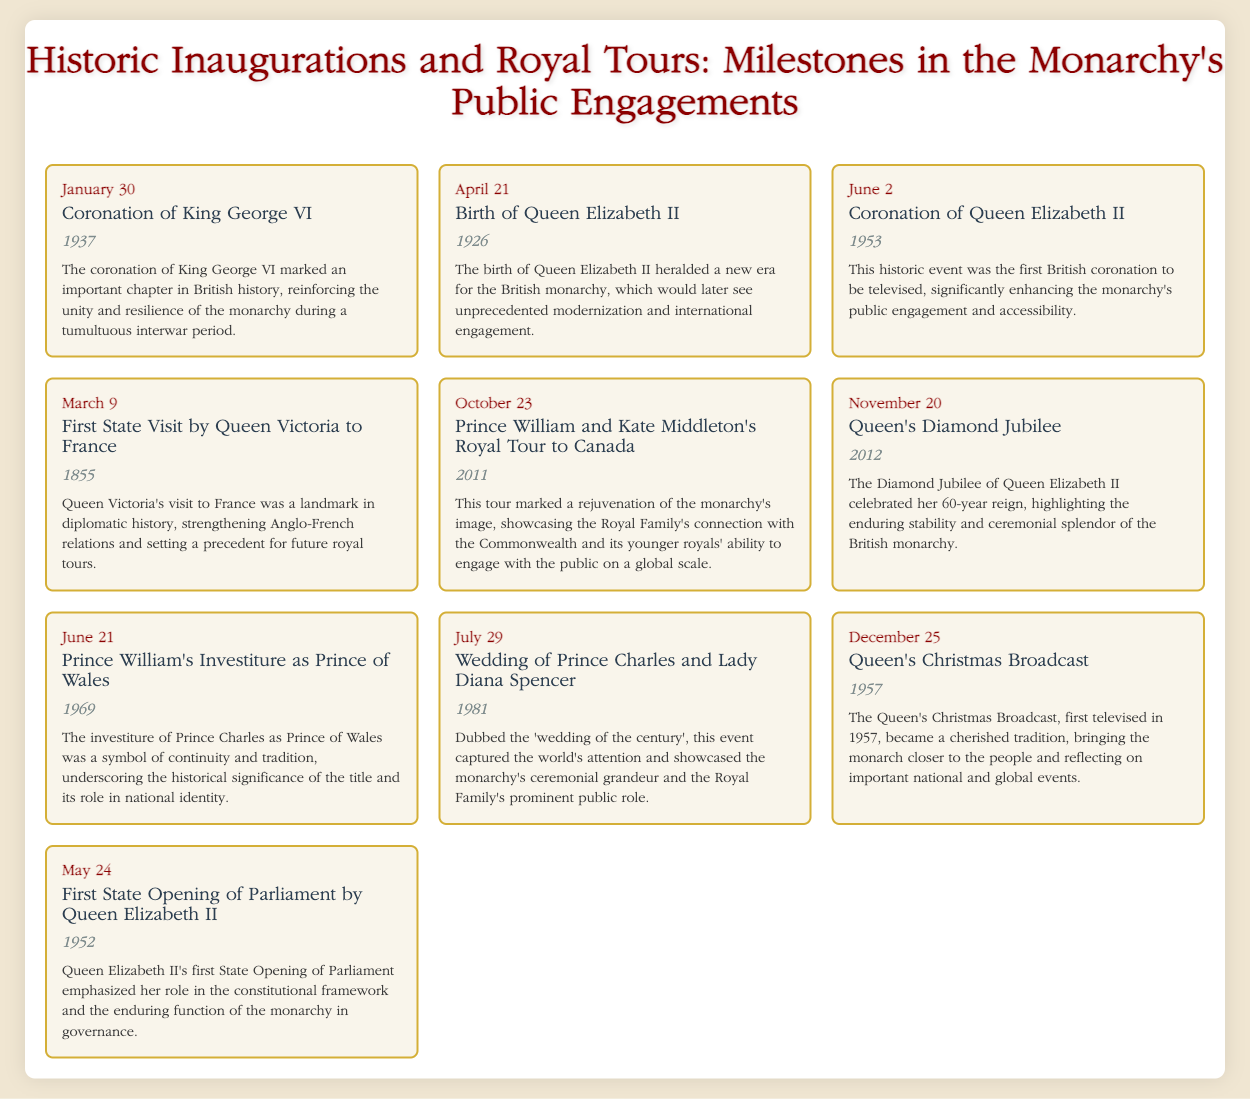what date is the coronation of King George VI? The document specifies that the coronation of King George VI took place on January 30.
Answer: January 30 what year was Queen Elizabeth II born? According to the document, Queen Elizabeth II was born in 1926.
Answer: 1926 what significant event took place on June 2, 1953? The document describes this date as the coronation of Queen Elizabeth II.
Answer: Coronation of Queen Elizabeth II how did Queen Victoria's first state visit impact Anglo-French relations? The document notes that this visit strengthened Anglo-French relations and set a precedent for future royal tours.
Answer: Strengthened Anglo-French relations what was the public response to the wedding of Prince Charles and Lady Diana Spencer? According to the document, this wedding was dubbed the "wedding of the century," capturing worldwide attention.
Answer: Wedding of the century how does the document describe the significance of the Diamond Jubilee of Queen Elizabeth II? The document highlights the Diamond Jubilee as a celebration of her 60-year reign, emphasizing stability and ceremonial splendor.
Answer: Celebrated her 60-year reign what was notable about Queen Elizabeth II's first State Opening of Parliament? The document states that it emphasized her role in the constitutional framework and the monarchy's enduring function in governance.
Answer: Emphasized her constitutional role which event marked a rejuvenation of the monarchy's image in 2011? The document indicates that Prince William and Kate Middleton's Royal Tour to Canada marked this rejuvenation.
Answer: Royal Tour to Canada what tradition began with the Queen's Christmas Broadcast in 1957? The document mentions that it became a cherished tradition, bringing the monarch closer to the people.
Answer: Cherished tradition 